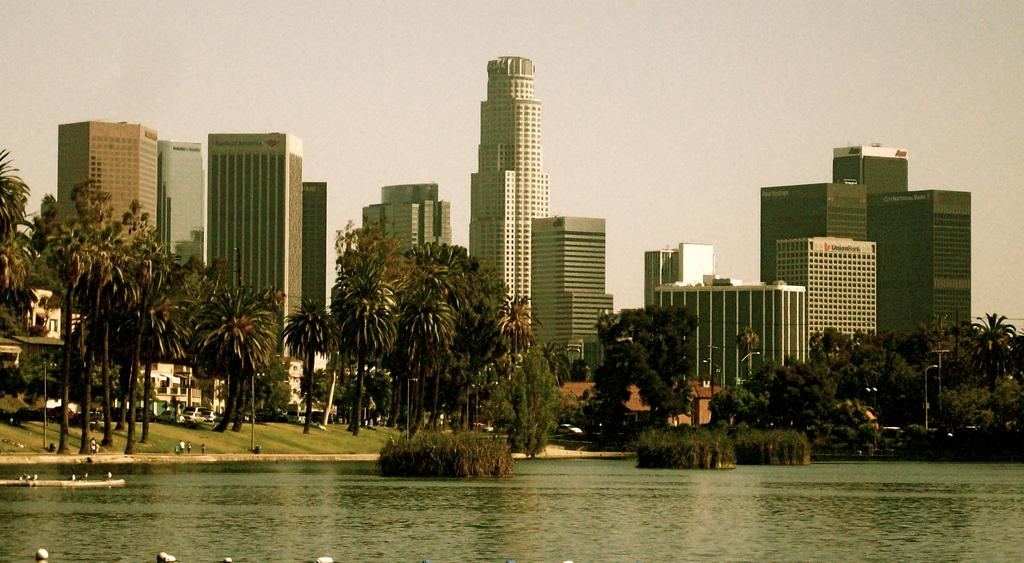What is the primary element visible in the image? There is water in the image. What type of natural elements can be seen in the image? There are trees in the image. What type of man-made structures are present in the image? There are buildings in the image. What type of infrastructure can be seen in the image? There are poles in the image. What type of transportation is visible in the image? There are vehicles in the image. Are there any people present in the image? Yes, there is a group of people in the image. What type of pipe is being used by the group of people in the image? There is no pipe visible in the image; the group of people is not using any such object. 